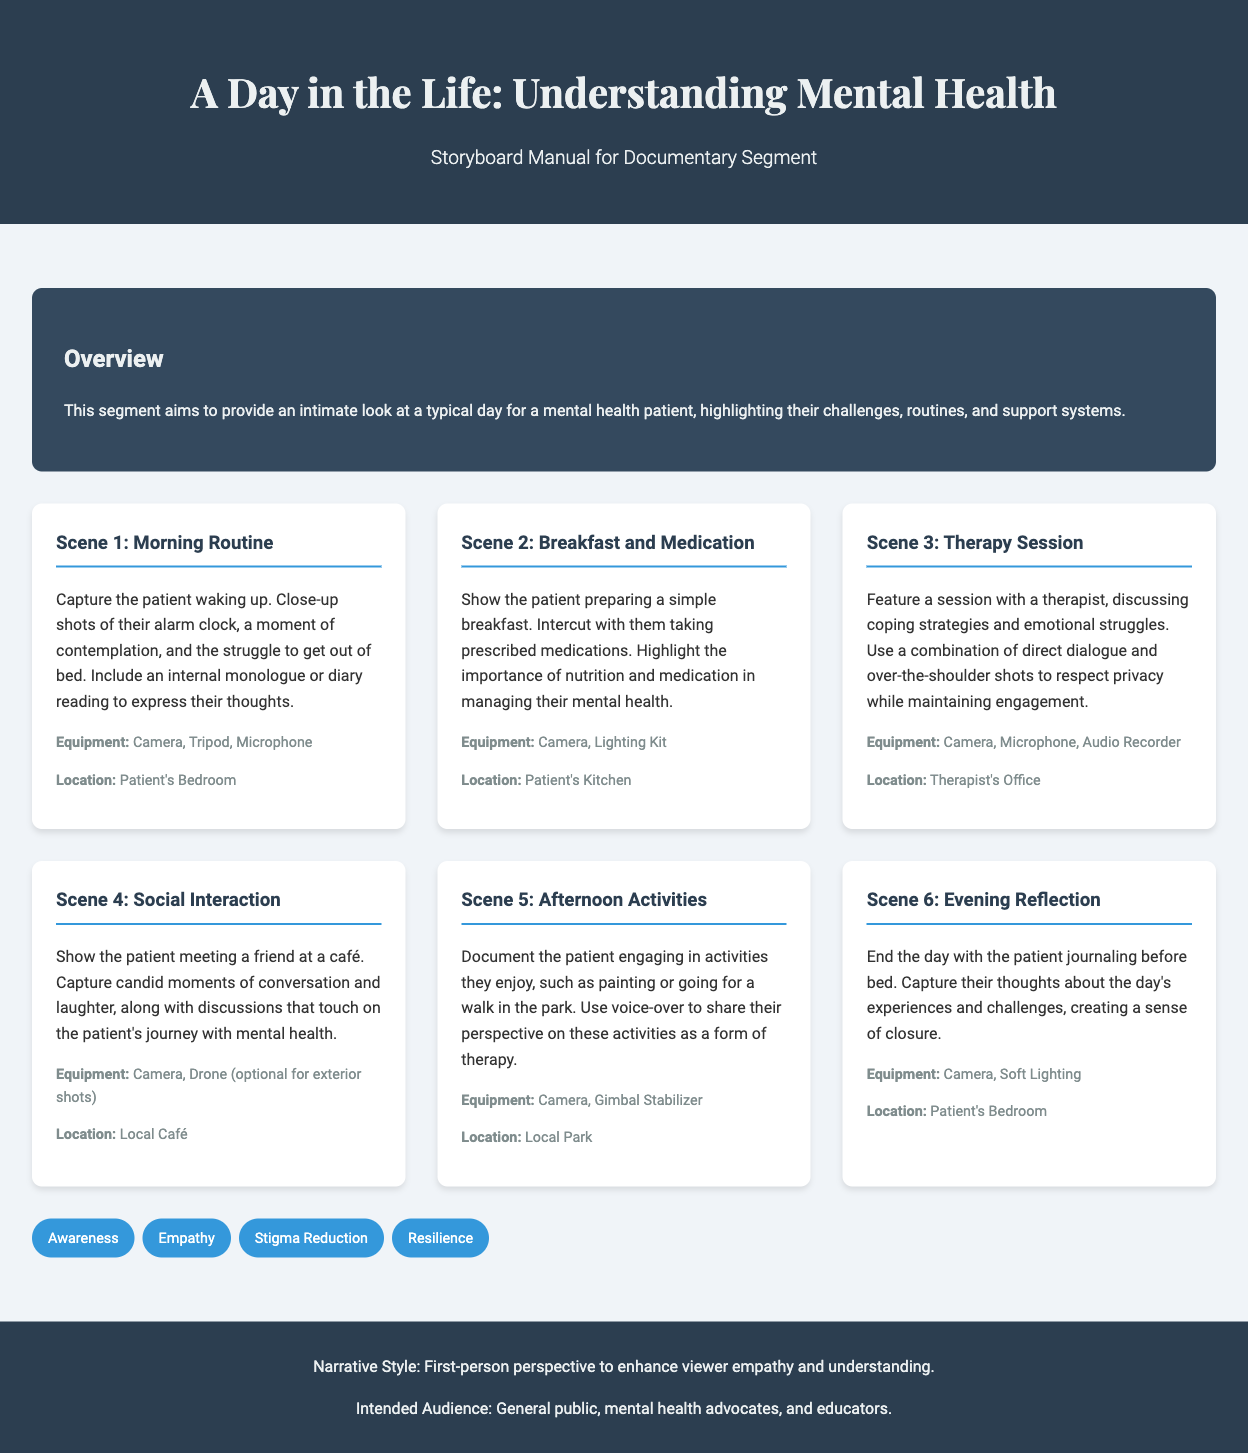What is the title of the storyboard manual? The title of the manual is explicitly mentioned at the top of the document.
Answer: A Day in the Life: Understanding Mental Health - Storyboard Manual What scene features the patient preparing a simple breakfast? This scene is identified in the scenes section of the document with detailed descriptions.
Answer: Scene 2: Breakfast and Medication How many themes are listed in the document? The themes are presented in a separate section at the end of the document, making it easy to quantify.
Answer: Four What type of perspective is used in the narrative style? The narrative style is stated directly in the footer, which summarizes the intended storytelling approach.
Answer: First-person perspective What equipment is required for the therapy session? The required equipment can be found in the scene description associated with the therapy session.
Answer: Camera, Microphone, Audio Recorder Which scene concludes the documentary segment? The last scene in the scenes section provides closure to the day's narrative.
Answer: Scene 6: Evening Reflection What location is designated for the patient’s morning routine? The location for each scene is clearly defined in the document, indicating where the filming takes place.
Answer: Patient's Bedroom What is the purpose of this documentary segment? The purpose is articulated in the overview section providing a succinct summary of the segment's intent.
Answer: To provide an intimate look at a typical day for a mental health patient 